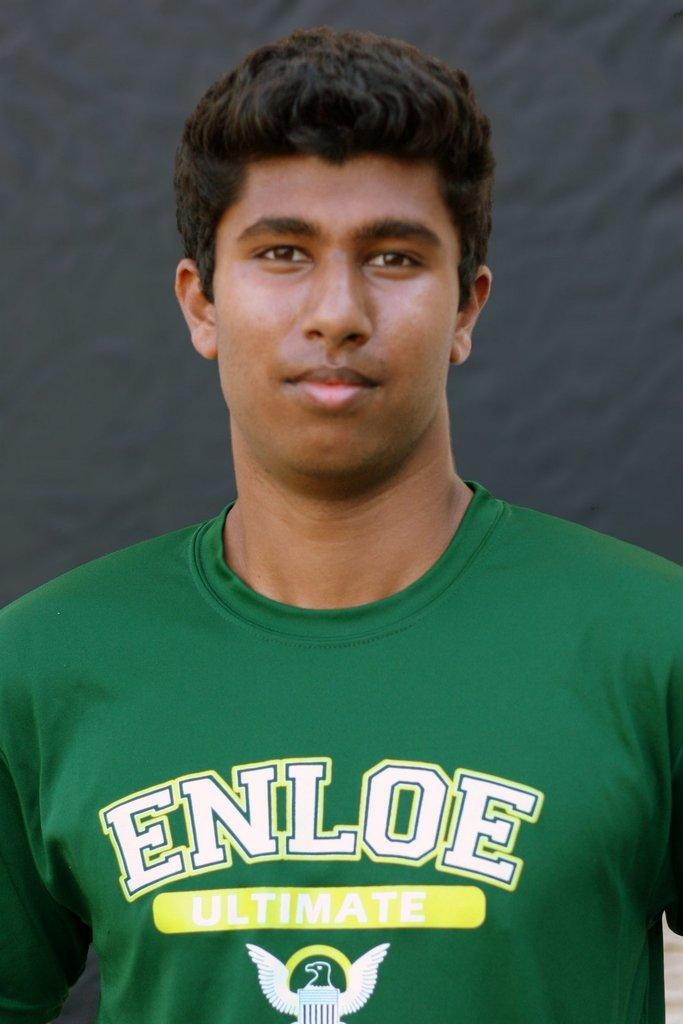<image>
Create a compact narrative representing the image presented. A man wearing a green shirt that reads ENLOE ULTIMATE. 